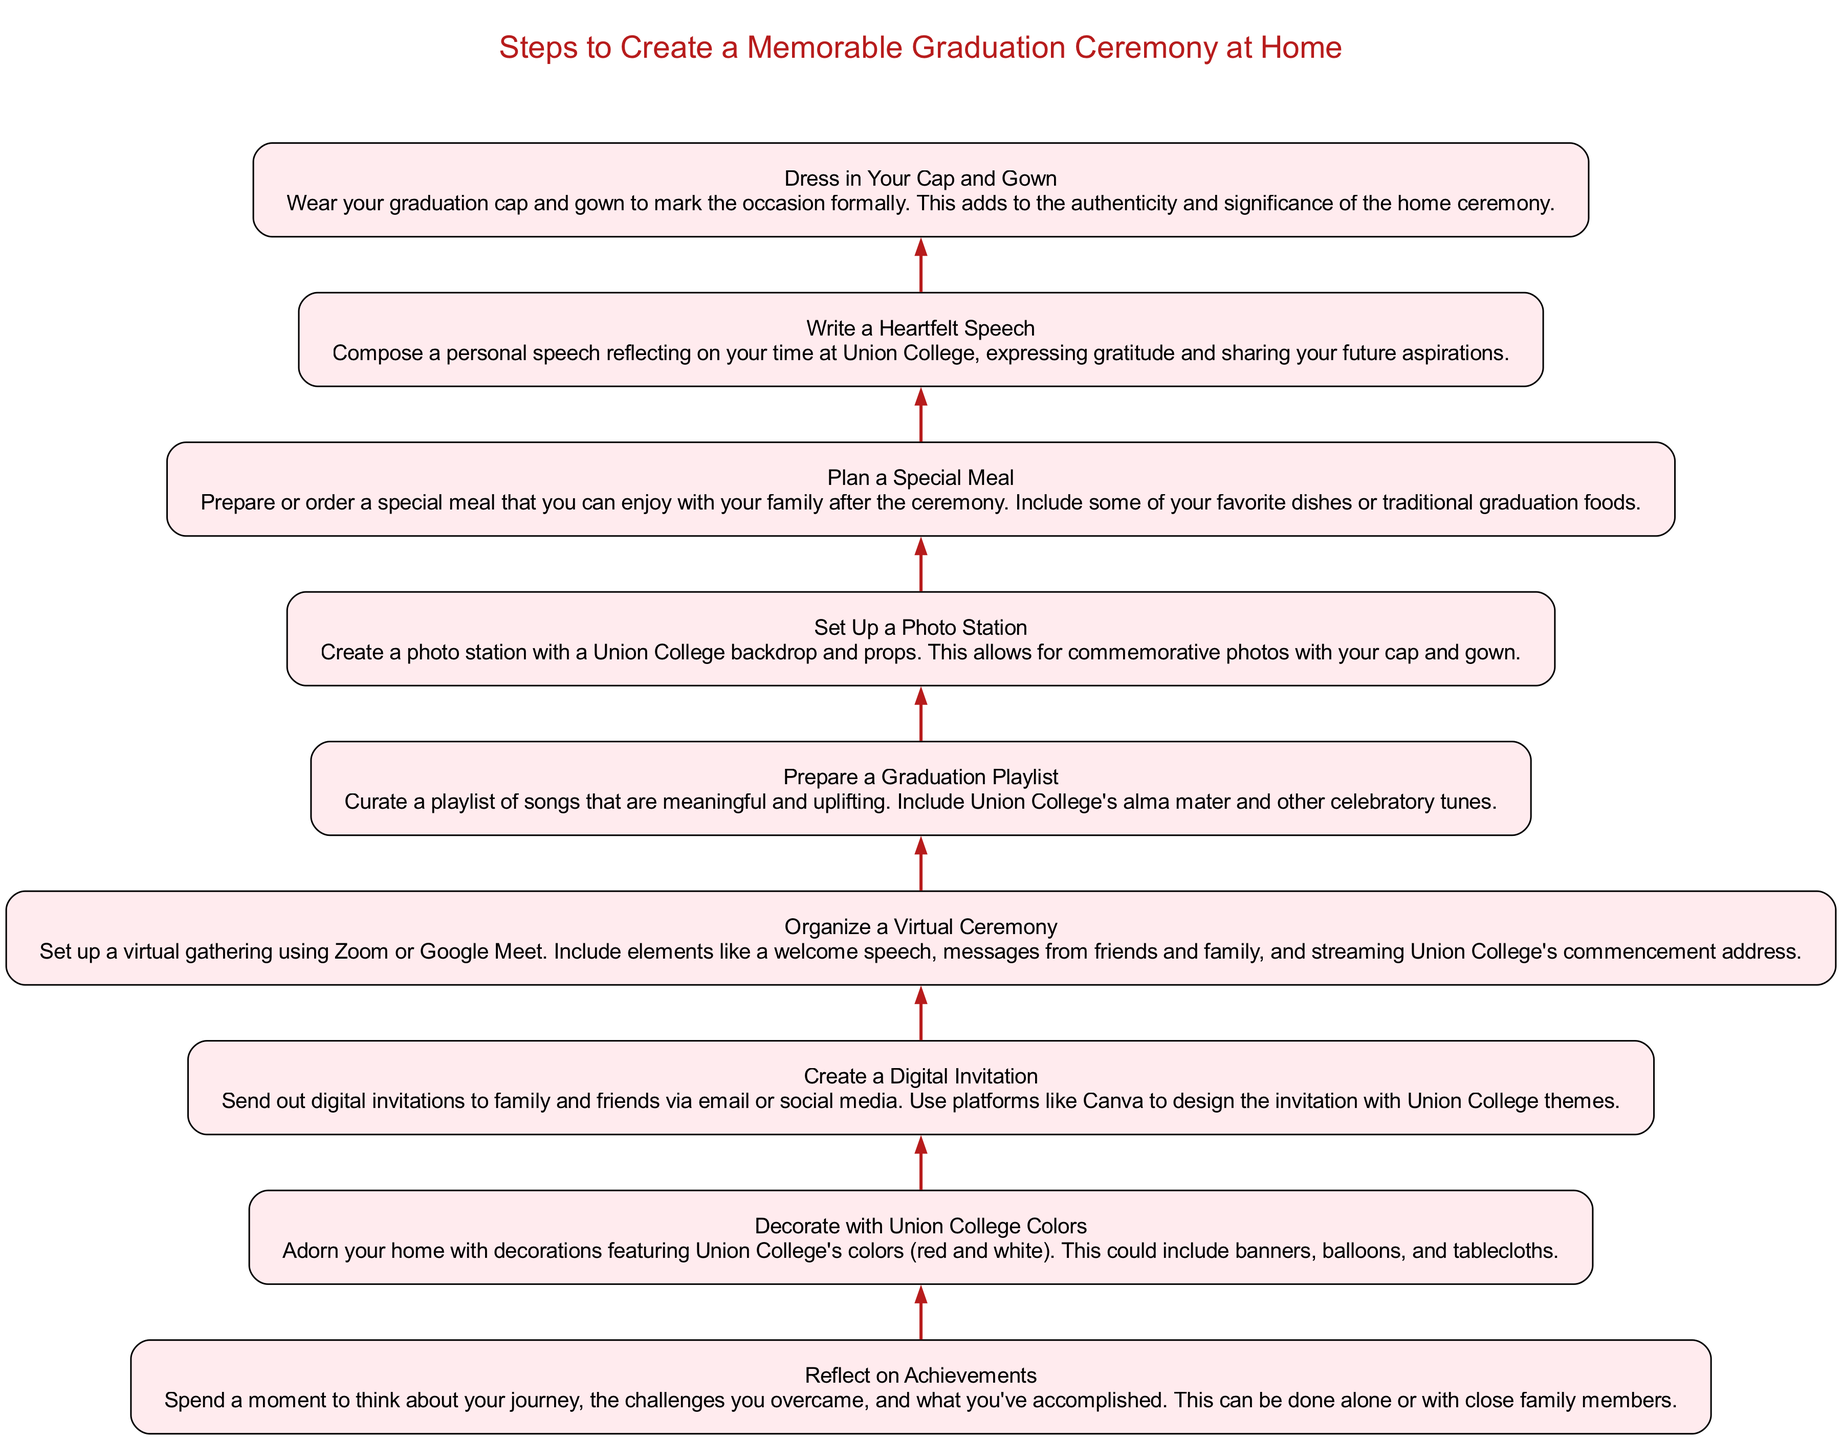What is the first step in the diagram? The first step is labeled "Reflect on Achievements," signifying the initial action in creating a memorable graduation ceremony. Since the steps flow from bottom to top, the one at the very bottom is the starting point.
Answer: Reflect on Achievements How many steps are included in the diagram? By counting each node listed in the steps, we can determine there are eight individual steps leading to the completion of the graduation ceremony plan.
Answer: 8 What color should the decorations feature according to the diagram? The diagram indicates that the decorations should feature Union College's colors, specifically mentioning red and white.
Answer: Red and white What is the relationship between "Dress in Your Cap and Gown" and "Write a Heartfelt Speech"? "Dress in Your Cap and Gown" is the last step, while "Write a Heartfelt Speech" is the second to last step. This indicates that writing the speech comes before dressing for the ceremony in the sequence.
Answer: Sequential relationship (one before the other) Which step comes directly after "Organize a Virtual Ceremony"? The next step listed after organizing the virtual ceremony is "Prepare a Graduation Playlist." Thus, following the flow from the previous node leads directly to this step.
Answer: Prepare a Graduation Playlist What is required at the step "Set Up a Photo Station"? The details specify creating a photo station with a Union College backdrop and props, indicating the necessity of these items for that step.
Answer: Backdrop and props Which step involves sending out invitations? The step dedicated to this task is "Create a Digital Invitation," which entails designing and sending invitations using email or social media.
Answer: Create a Digital Invitation What is the purpose of preparing a special meal in the diagram? The purpose is to enjoy a special meal with family after the ceremony, highlighting the celebratory nature of the occasion after the formal rituals.
Answer: Celebration with family What type of gathering is suggested in the step "Organize a Virtual Ceremony"? The gathering suggested is a virtual one, specifically through platforms like Zoom or Google Meet, allowing attendees to participate remotely.
Answer: Virtual gathering 